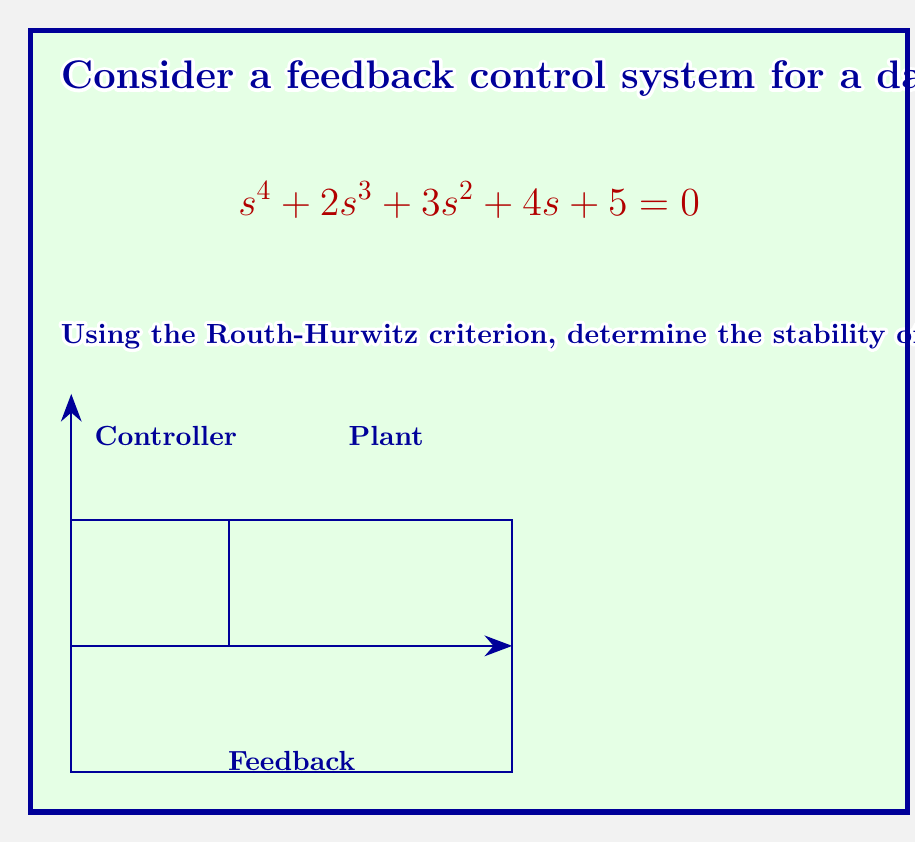Help me with this question. To analyze the stability using the Routh-Hurwitz criterion, we follow these steps:

1) Construct the Routh array:

   $$\begin{array}{c|cccc}
   s^4 & 1 & 3 & 5 \\
   s^3 & 2 & 4 & 0 \\
   s^2 & b_1 & b_2 & \\
   s^1 & c_1 & \\
   s^0 & d_1 &
   \end{array}$$

2) Calculate $b_1$:
   $$b_1 = \frac{(2)(3) - (1)(4)}{2} = 1$$

3) Calculate $b_2$:
   $$b_2 = \frac{(2)(5) - (1)(0)}{2} = 5$$

4) Calculate $c_1$:
   $$c_1 = \frac{(1)(4) - (2)(5)}{1} = -6$$

5) Calculate $d_1$:
   $$d_1 = \frac{(-6)(5) - (1)(0)}{-6} = 5$$

6) The complete Routh array:

   $$\begin{array}{c|cccc}
   s^4 & 1 & 3 & 5 \\
   s^3 & 2 & 4 & 0 \\
   s^2 & 1 & 5 & \\
   s^1 & -6 & \\
   s^0 & 5 &
   \end{array}$$

7) Count the sign changes in the first column: 1 → 2 → 1 → -6 → 5

There are two sign changes in the first column of the Routh array.

According to the Routh-Hurwitz criterion, the number of sign changes in the first column of the Routh array equals the number of roots with positive real parts.
Answer: 2 roots have positive real parts 